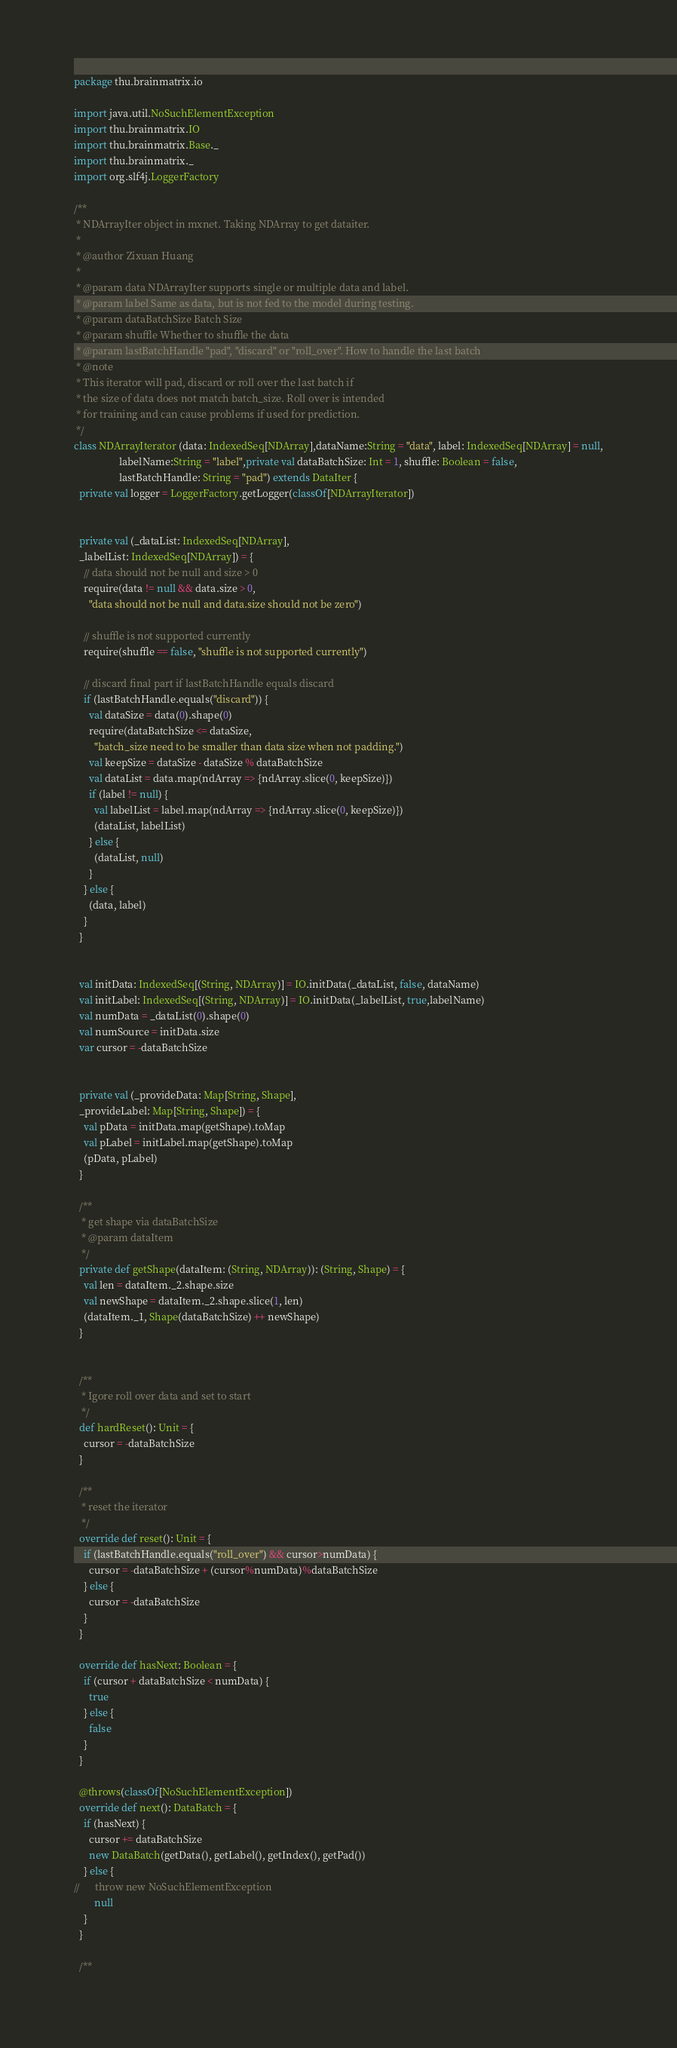<code> <loc_0><loc_0><loc_500><loc_500><_Scala_>package thu.brainmatrix.io

import java.util.NoSuchElementException
import thu.brainmatrix.IO
import thu.brainmatrix.Base._
import thu.brainmatrix._
import org.slf4j.LoggerFactory

/**
 * NDArrayIter object in mxnet. Taking NDArray to get dataiter.
 *
 * @author Zixuan Huang
 *
 * @param data NDArrayIter supports single or multiple data and label.
 * @param label Same as data, but is not fed to the model during testing.
 * @param dataBatchSize Batch Size
 * @param shuffle Whether to shuffle the data
 * @param lastBatchHandle "pad", "discard" or "roll_over". How to handle the last batch
 * @note
 * This iterator will pad, discard or roll over the last batch if
 * the size of data does not match batch_size. Roll over is intended
 * for training and can cause problems if used for prediction.
 */
class NDArrayIterator (data: IndexedSeq[NDArray],dataName:String = "data", label: IndexedSeq[NDArray] = null,
                  labelName:String = "label",private val dataBatchSize: Int = 1, shuffle: Boolean = false,
                  lastBatchHandle: String = "pad") extends DataIter {
  private val logger = LoggerFactory.getLogger(classOf[NDArrayIterator])


  private val (_dataList: IndexedSeq[NDArray],
  _labelList: IndexedSeq[NDArray]) = {
    // data should not be null and size > 0
    require(data != null && data.size > 0,
      "data should not be null and data.size should not be zero")

    // shuffle is not supported currently
    require(shuffle == false, "shuffle is not supported currently")

    // discard final part if lastBatchHandle equals discard
    if (lastBatchHandle.equals("discard")) {
      val dataSize = data(0).shape(0)
      require(dataBatchSize <= dataSize,
        "batch_size need to be smaller than data size when not padding.")
      val keepSize = dataSize - dataSize % dataBatchSize
      val dataList = data.map(ndArray => {ndArray.slice(0, keepSize)})
      if (label != null) {
        val labelList = label.map(ndArray => {ndArray.slice(0, keepSize)})
        (dataList, labelList)
      } else {
        (dataList, null)
      }
    } else {
      (data, label)
    }
  }


  val initData: IndexedSeq[(String, NDArray)] = IO.initData(_dataList, false, dataName)
  val initLabel: IndexedSeq[(String, NDArray)] = IO.initData(_labelList, true,labelName)
  val numData = _dataList(0).shape(0)
  val numSource = initData.size
  var cursor = -dataBatchSize


  private val (_provideData: Map[String, Shape],
  _provideLabel: Map[String, Shape]) = {
    val pData = initData.map(getShape).toMap
    val pLabel = initLabel.map(getShape).toMap
    (pData, pLabel)
  }

  /**
   * get shape via dataBatchSize
   * @param dataItem
   */
  private def getShape(dataItem: (String, NDArray)): (String, Shape) = {
    val len = dataItem._2.shape.size
    val newShape = dataItem._2.shape.slice(1, len)
    (dataItem._1, Shape(dataBatchSize) ++ newShape)
  }


  /**
   * Igore roll over data and set to start
   */
  def hardReset(): Unit = {
    cursor = -dataBatchSize
  }

  /**
   * reset the iterator
   */
  override def reset(): Unit = {
    if (lastBatchHandle.equals("roll_over") && cursor>numData) {
      cursor = -dataBatchSize + (cursor%numData)%dataBatchSize
    } else {
      cursor = -dataBatchSize
    }
  }

  override def hasNext: Boolean = {
    if (cursor + dataBatchSize < numData) {
      true
    } else {
      false
    }
  }

  @throws(classOf[NoSuchElementException])
  override def next(): DataBatch = {
    if (hasNext) {
      cursor += dataBatchSize
      new DataBatch(getData(), getLabel(), getIndex(), getPad())
    } else {
//      throw new NoSuchElementException
        null
    }
  }

  /**</code> 